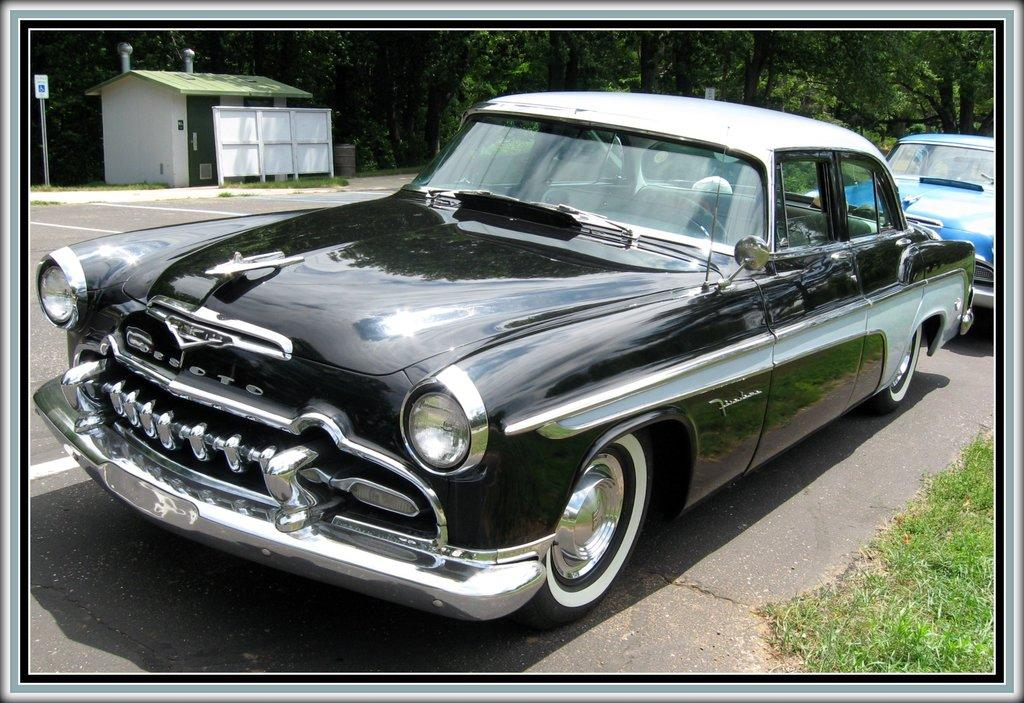What are the main subjects in the center of the image? There are two cars in the center of the image. What is located at the bottom of the image? There is a road at the bottom of the image. Are there any other vehicles visible in the image? Yes, there are additional cars on the road. What can be seen in the background of the image? There are trees, a house, a pole, and boards in the background of the image. What type of poison is being sprayed by the chickens in the image? There are no chickens present in the image, so it is not possible to determine if any poison is being sprayed. 